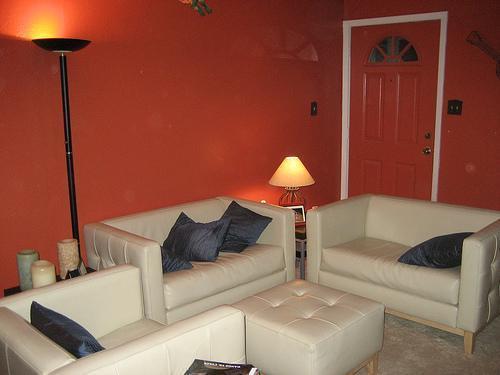How many sofas are in this image?
Give a very brief answer. 2. How many pillows are there?
Give a very brief answer. 5. How many candles are on the end table?
Give a very brief answer. 3. 